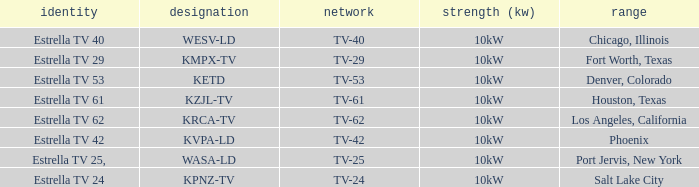What's the power output for channel tv-29? 10kW. 